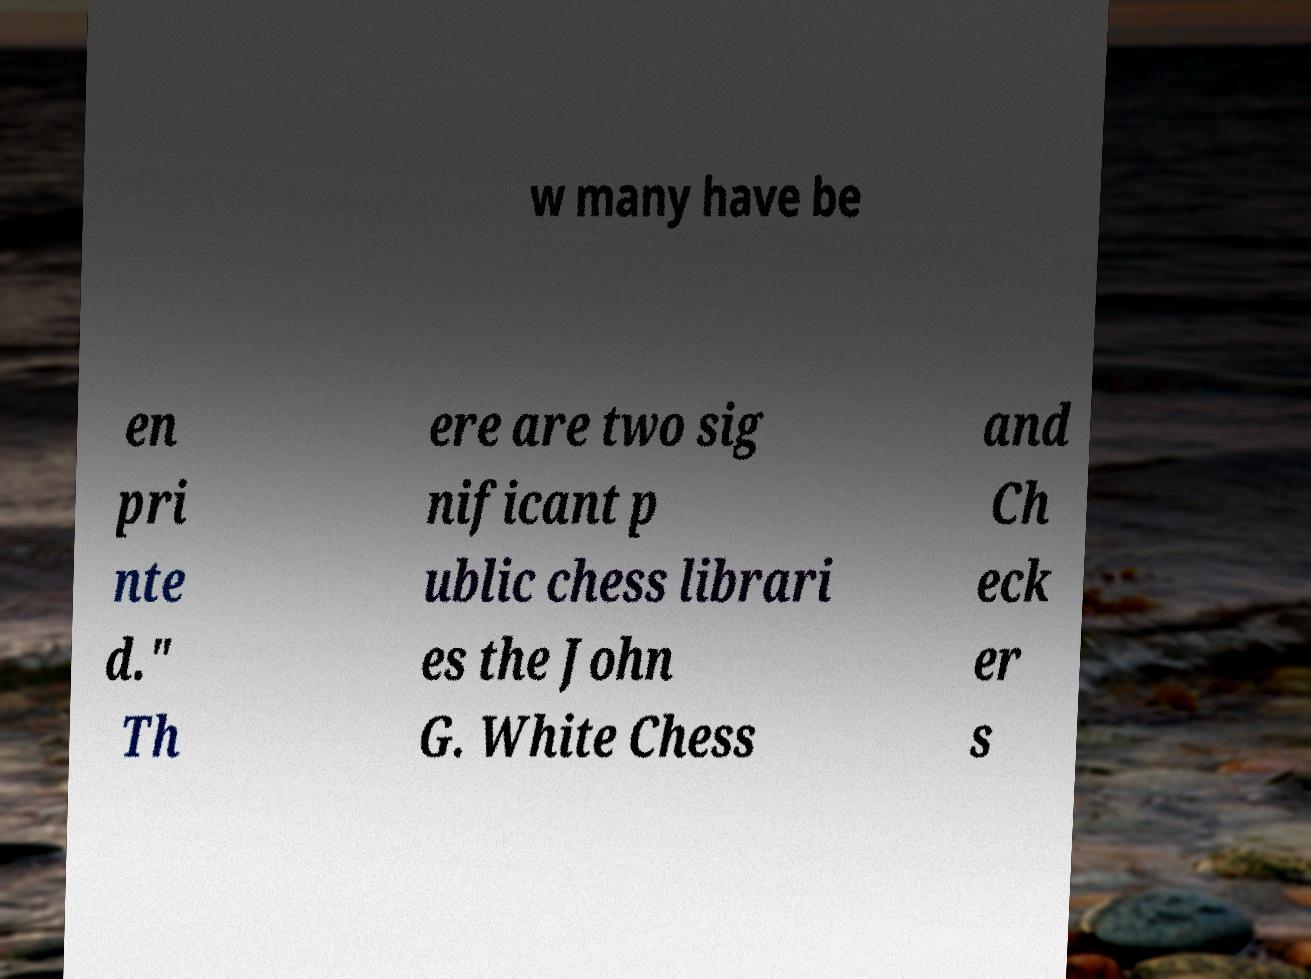I need the written content from this picture converted into text. Can you do that? w many have be en pri nte d." Th ere are two sig nificant p ublic chess librari es the John G. White Chess and Ch eck er s 